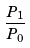Convert formula to latex. <formula><loc_0><loc_0><loc_500><loc_500>\frac { P _ { 1 } } { P _ { 0 } }</formula> 